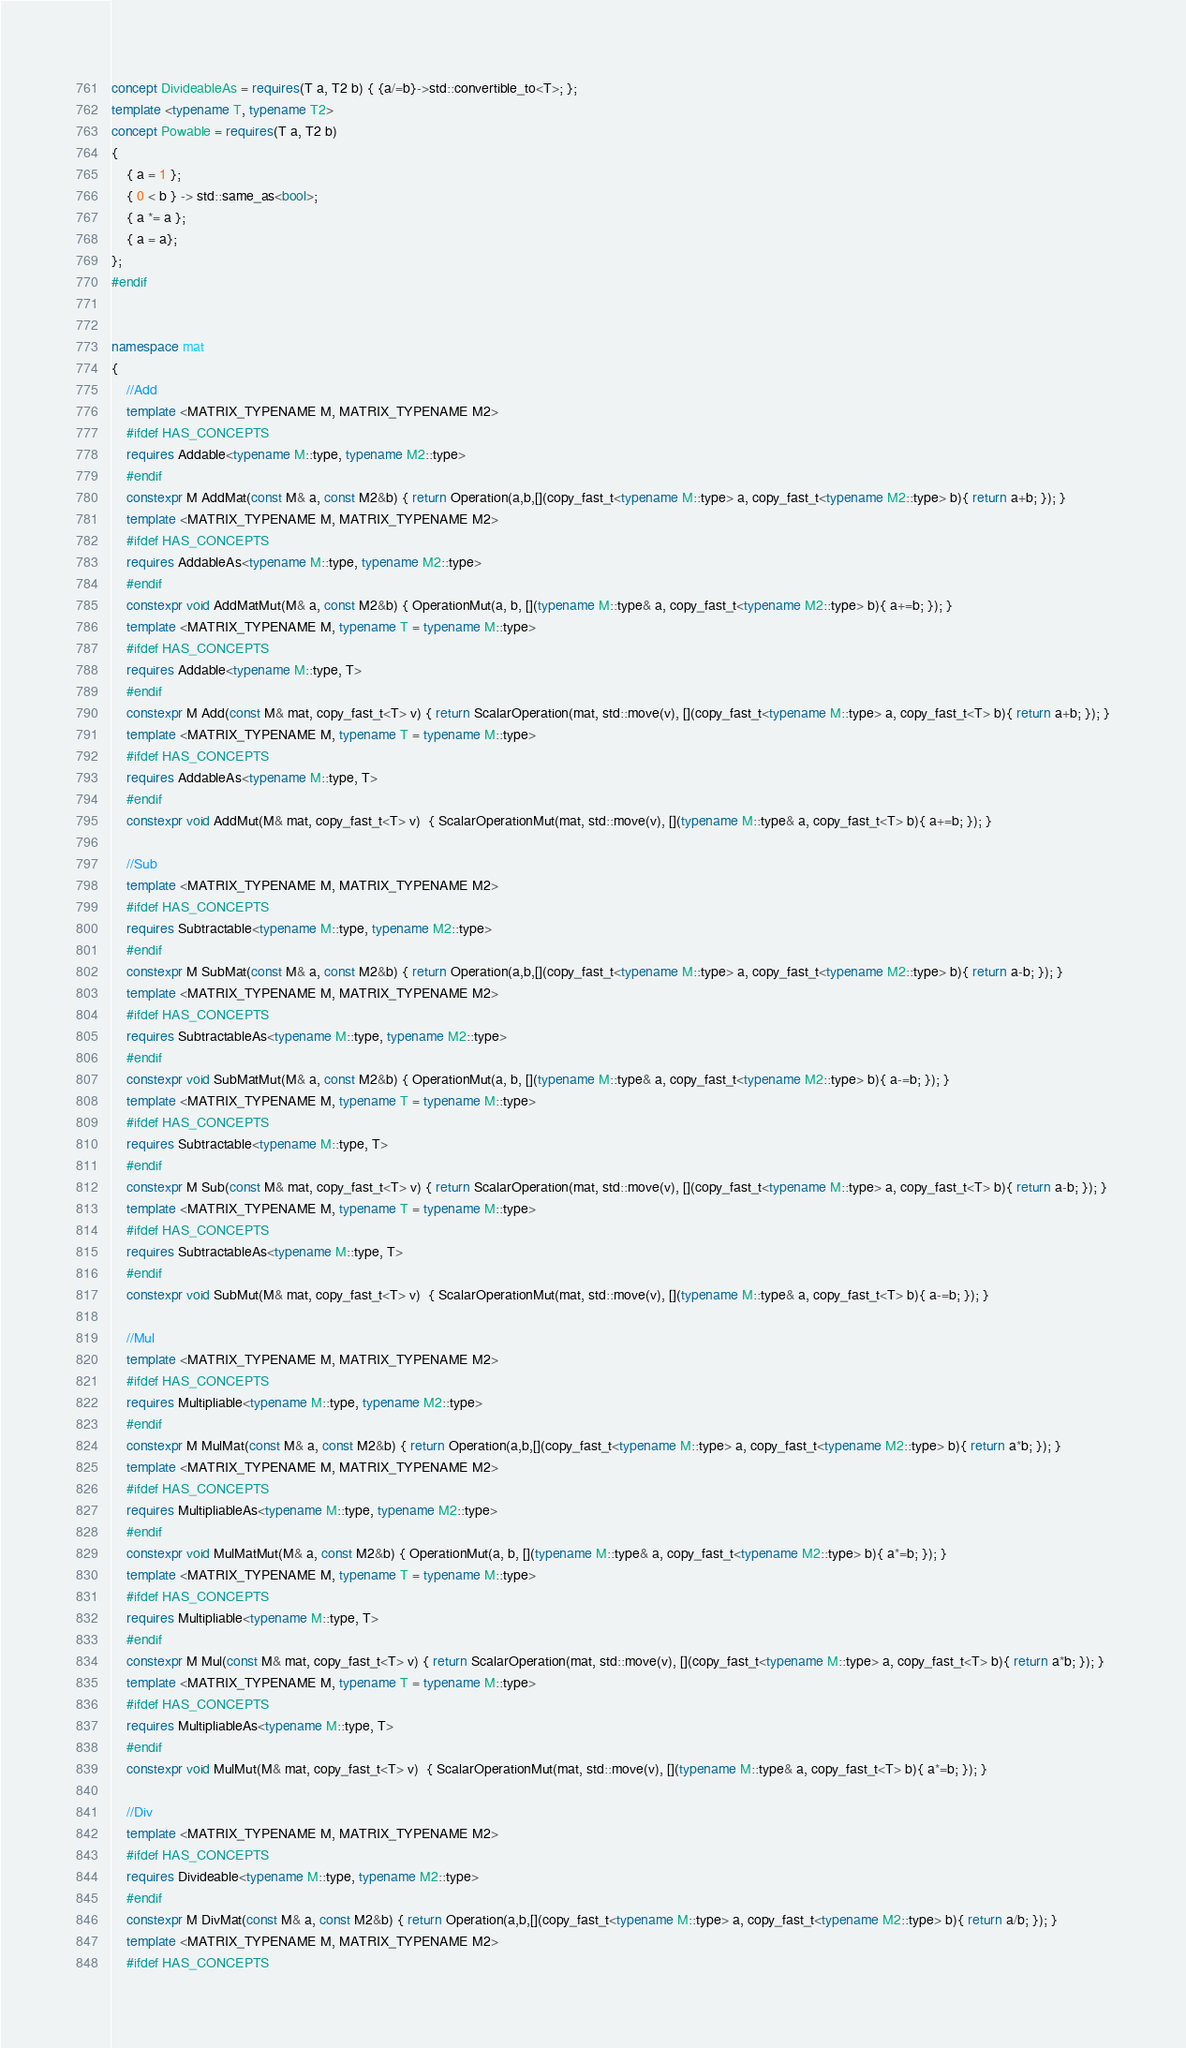<code> <loc_0><loc_0><loc_500><loc_500><_C++_>concept DivideableAs = requires(T a, T2 b) { {a/=b}->std::convertible_to<T>; };
template <typename T, typename T2>
concept Powable = requires(T a, T2 b)
{
    { a = 1 };
    { 0 < b } -> std::same_as<bool>;
    { a *= a };
    { a = a};
};
#endif


namespace mat
{
    //Add
    template <MATRIX_TYPENAME M, MATRIX_TYPENAME M2>
    #ifdef HAS_CONCEPTS 
    requires Addable<typename M::type, typename M2::type>
    #endif
    constexpr M AddMat(const M& a, const M2&b) { return Operation(a,b,[](copy_fast_t<typename M::type> a, copy_fast_t<typename M2::type> b){ return a+b; }); }
    template <MATRIX_TYPENAME M, MATRIX_TYPENAME M2>
    #ifdef HAS_CONCEPTS 
    requires AddableAs<typename M::type, typename M2::type>
    #endif
    constexpr void AddMatMut(M& a, const M2&b) { OperationMut(a, b, [](typename M::type& a, copy_fast_t<typename M2::type> b){ a+=b; }); }
    template <MATRIX_TYPENAME M, typename T = typename M::type>
    #ifdef HAS_CONCEPTS 
    requires Addable<typename M::type, T>
    #endif
    constexpr M Add(const M& mat, copy_fast_t<T> v) { return ScalarOperation(mat, std::move(v), [](copy_fast_t<typename M::type> a, copy_fast_t<T> b){ return a+b; }); }
    template <MATRIX_TYPENAME M, typename T = typename M::type>
    #ifdef HAS_CONCEPTS 
    requires AddableAs<typename M::type, T>
    #endif
    constexpr void AddMut(M& mat, copy_fast_t<T> v)  { ScalarOperationMut(mat, std::move(v), [](typename M::type& a, copy_fast_t<T> b){ a+=b; }); }

    //Sub
    template <MATRIX_TYPENAME M, MATRIX_TYPENAME M2>
    #ifdef HAS_CONCEPTS 
    requires Subtractable<typename M::type, typename M2::type>
    #endif
    constexpr M SubMat(const M& a, const M2&b) { return Operation(a,b,[](copy_fast_t<typename M::type> a, copy_fast_t<typename M2::type> b){ return a-b; }); }
    template <MATRIX_TYPENAME M, MATRIX_TYPENAME M2>
    #ifdef HAS_CONCEPTS 
    requires SubtractableAs<typename M::type, typename M2::type>
    #endif
    constexpr void SubMatMut(M& a, const M2&b) { OperationMut(a, b, [](typename M::type& a, copy_fast_t<typename M2::type> b){ a-=b; }); }
    template <MATRIX_TYPENAME M, typename T = typename M::type>
    #ifdef HAS_CONCEPTS 
    requires Subtractable<typename M::type, T>
    #endif
    constexpr M Sub(const M& mat, copy_fast_t<T> v) { return ScalarOperation(mat, std::move(v), [](copy_fast_t<typename M::type> a, copy_fast_t<T> b){ return a-b; }); }
    template <MATRIX_TYPENAME M, typename T = typename M::type>
    #ifdef HAS_CONCEPTS 
    requires SubtractableAs<typename M::type, T>
    #endif
    constexpr void SubMut(M& mat, copy_fast_t<T> v)  { ScalarOperationMut(mat, std::move(v), [](typename M::type& a, copy_fast_t<T> b){ a-=b; }); }

    //Mul
    template <MATRIX_TYPENAME M, MATRIX_TYPENAME M2>
    #ifdef HAS_CONCEPTS 
    requires Multipliable<typename M::type, typename M2::type>
    #endif
    constexpr M MulMat(const M& a, const M2&b) { return Operation(a,b,[](copy_fast_t<typename M::type> a, copy_fast_t<typename M2::type> b){ return a*b; }); }
    template <MATRIX_TYPENAME M, MATRIX_TYPENAME M2>
    #ifdef HAS_CONCEPTS 
    requires MultipliableAs<typename M::type, typename M2::type>
    #endif
    constexpr void MulMatMut(M& a, const M2&b) { OperationMut(a, b, [](typename M::type& a, copy_fast_t<typename M2::type> b){ a*=b; }); }
    template <MATRIX_TYPENAME M, typename T = typename M::type>
    #ifdef HAS_CONCEPTS 
    requires Multipliable<typename M::type, T>
    #endif
    constexpr M Mul(const M& mat, copy_fast_t<T> v) { return ScalarOperation(mat, std::move(v), [](copy_fast_t<typename M::type> a, copy_fast_t<T> b){ return a*b; }); }
    template <MATRIX_TYPENAME M, typename T = typename M::type>
    #ifdef HAS_CONCEPTS 
    requires MultipliableAs<typename M::type, T>
    #endif
    constexpr void MulMut(M& mat, copy_fast_t<T> v)  { ScalarOperationMut(mat, std::move(v), [](typename M::type& a, copy_fast_t<T> b){ a*=b; }); }

    //Div
    template <MATRIX_TYPENAME M, MATRIX_TYPENAME M2>
    #ifdef HAS_CONCEPTS 
    requires Divideable<typename M::type, typename M2::type>
    #endif
    constexpr M DivMat(const M& a, const M2&b) { return Operation(a,b,[](copy_fast_t<typename M::type> a, copy_fast_t<typename M2::type> b){ return a/b; }); }
    template <MATRIX_TYPENAME M, MATRIX_TYPENAME M2>
    #ifdef HAS_CONCEPTS </code> 